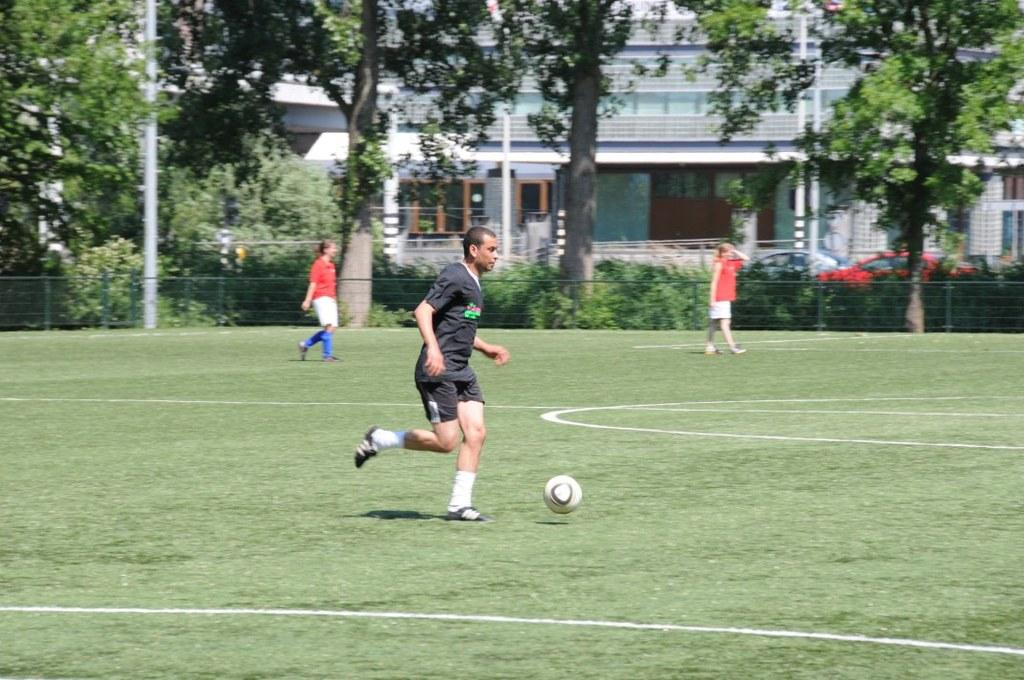What are the persons in the image doing? The persons in the image are playing. What can be seen in the background of the image? There are trees and a building in the background of the image. What type of surface is the persons playing on? There is grass on the ground in the image. What type of baby cream is visible in the image? There is no baby cream present in the image. What type of frame surrounds the image? The provided facts do not mention a frame surrounding the image. 